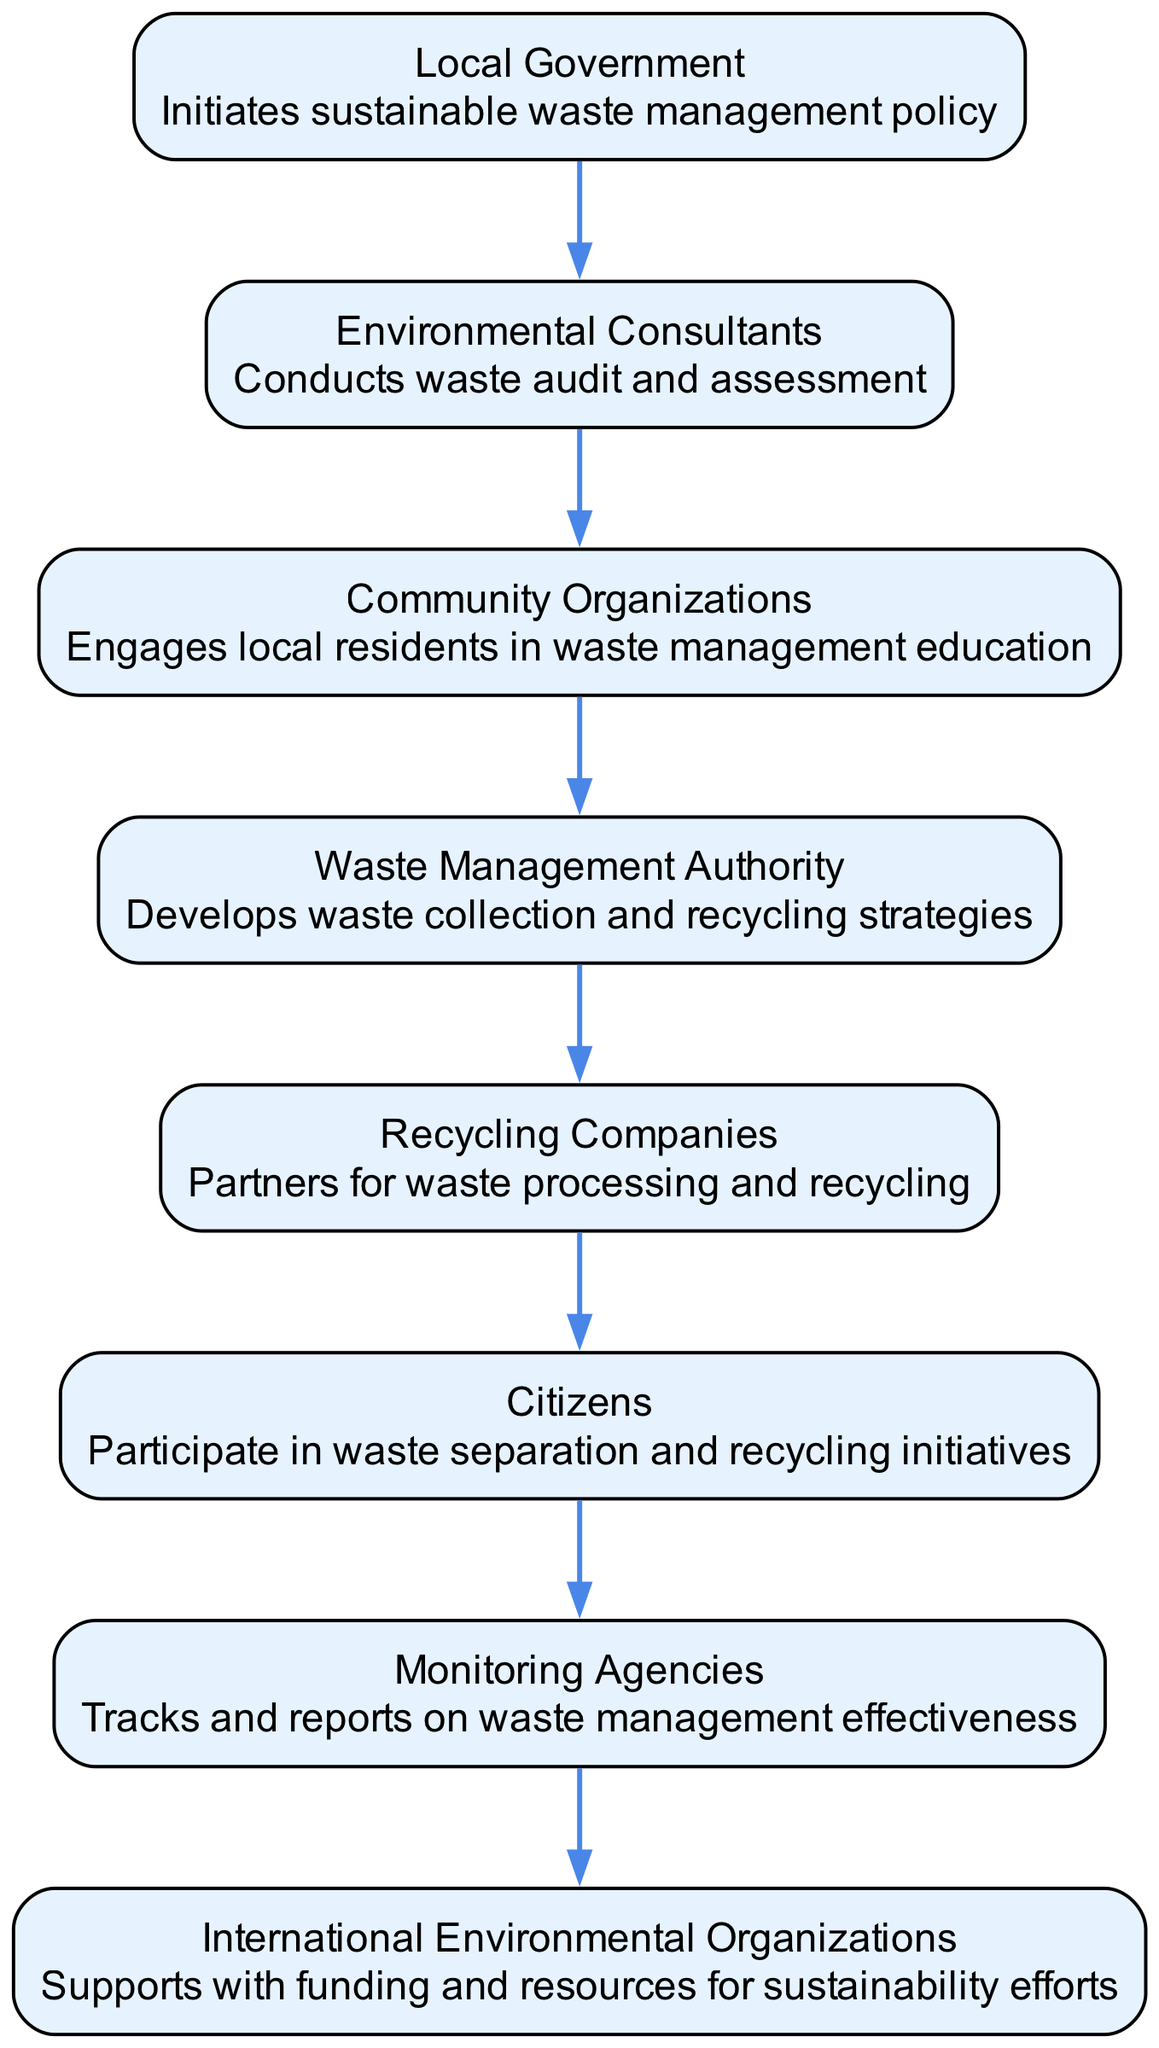What is the first action in the workflow? The first action in the workflow is performed by the Local Government, which initiates the sustainable waste management policy. This is depicted at the top of the sequence diagram.
Answer: Initiates sustainable waste management policy How many entities are involved in the workflow? By counting the distinct entities listed in the diagram, we have eight: Local Government, Environmental Consultants, Community Organizations, Waste Management Authority, Recycling Companies, Citizens, Monitoring Agencies, and International Environmental Organizations.
Answer: Eight What role does the Waste Management Authority play in the workflow? The Waste Management Authority develops waste collection and recycling strategies, indicating its key role in shaping the operational structure of the waste management system.
Answer: Develops waste collection and recycling strategies Which entity collaborates with Recycling Companies? The Recycling Companies partner with the Waste Management Authority for waste processing and recycling. This relationship shows the collaboration necessary for an effective recycling strategy in urban waste management.
Answer: Waste Management Authority What is the final action taken in the workflow? The sequence diagram reflects that the last action is performed by the Monitoring Agencies, which track and report on waste management effectiveness, indicating the importance of oversight in sustainability efforts.
Answer: Tracks and reports on waste management effectiveness How many steps are there from Local Government to Citizens? Tracing the sequence from Local Government initiating the policy to Citizens participating in waste separation and recycling initiatives, there are four steps or actions in between.
Answer: Four What is the purpose of involving Community Organizations? Community Organizations engage local residents in waste management education, which aims to raise awareness and promote active participation in sustainability efforts among the public.
Answer: Engages local residents in waste management education Which entity supports the workflow with funding and resources? The International Environmental Organizations provide support in the form of funding and resources, which is crucial for the sustainability efforts depicted in the workflow diagram.
Answer: Supports with funding and resources for sustainability efforts 